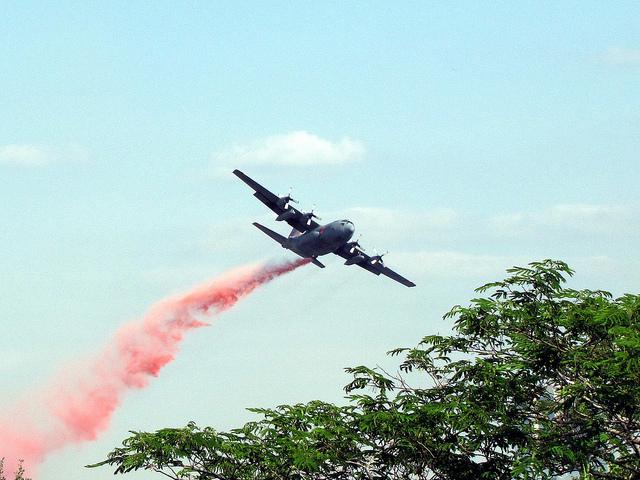Is this plane dumping anything?
Keep it brief. Yes. Is the plane being filmed from the ground?
Answer briefly. Yes. How many engines does this plane have?
Be succinct. 4. 